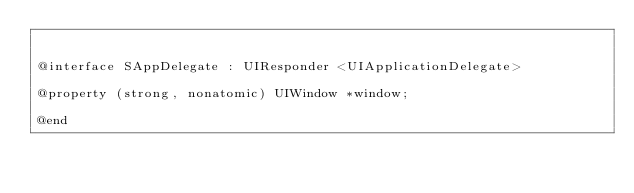<code> <loc_0><loc_0><loc_500><loc_500><_C_>

@interface SAppDelegate : UIResponder <UIApplicationDelegate>

@property (strong, nonatomic) UIWindow *window;

@end
</code> 